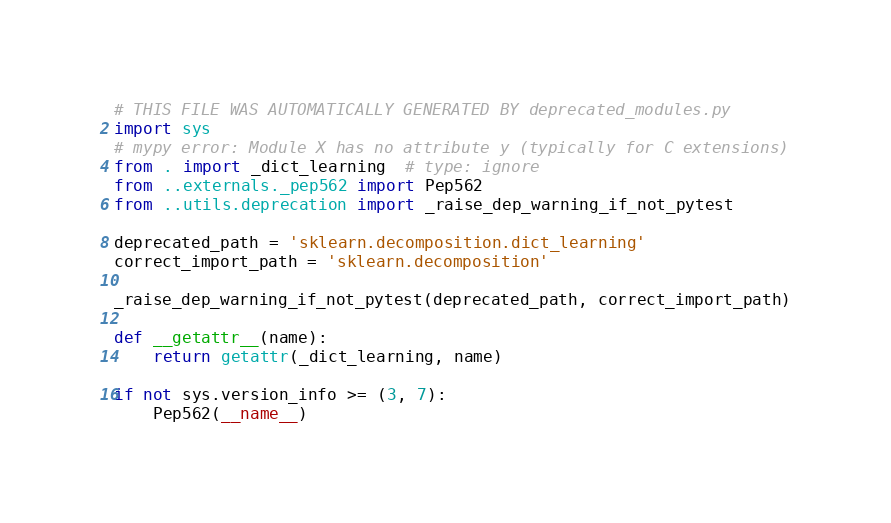<code> <loc_0><loc_0><loc_500><loc_500><_Python_>
# THIS FILE WAS AUTOMATICALLY GENERATED BY deprecated_modules.py
import sys
# mypy error: Module X has no attribute y (typically for C extensions)
from . import _dict_learning  # type: ignore
from ..externals._pep562 import Pep562
from ..utils.deprecation import _raise_dep_warning_if_not_pytest

deprecated_path = 'sklearn.decomposition.dict_learning'
correct_import_path = 'sklearn.decomposition'

_raise_dep_warning_if_not_pytest(deprecated_path, correct_import_path)

def __getattr__(name):
    return getattr(_dict_learning, name)

if not sys.version_info >= (3, 7):
    Pep562(__name__)
</code> 